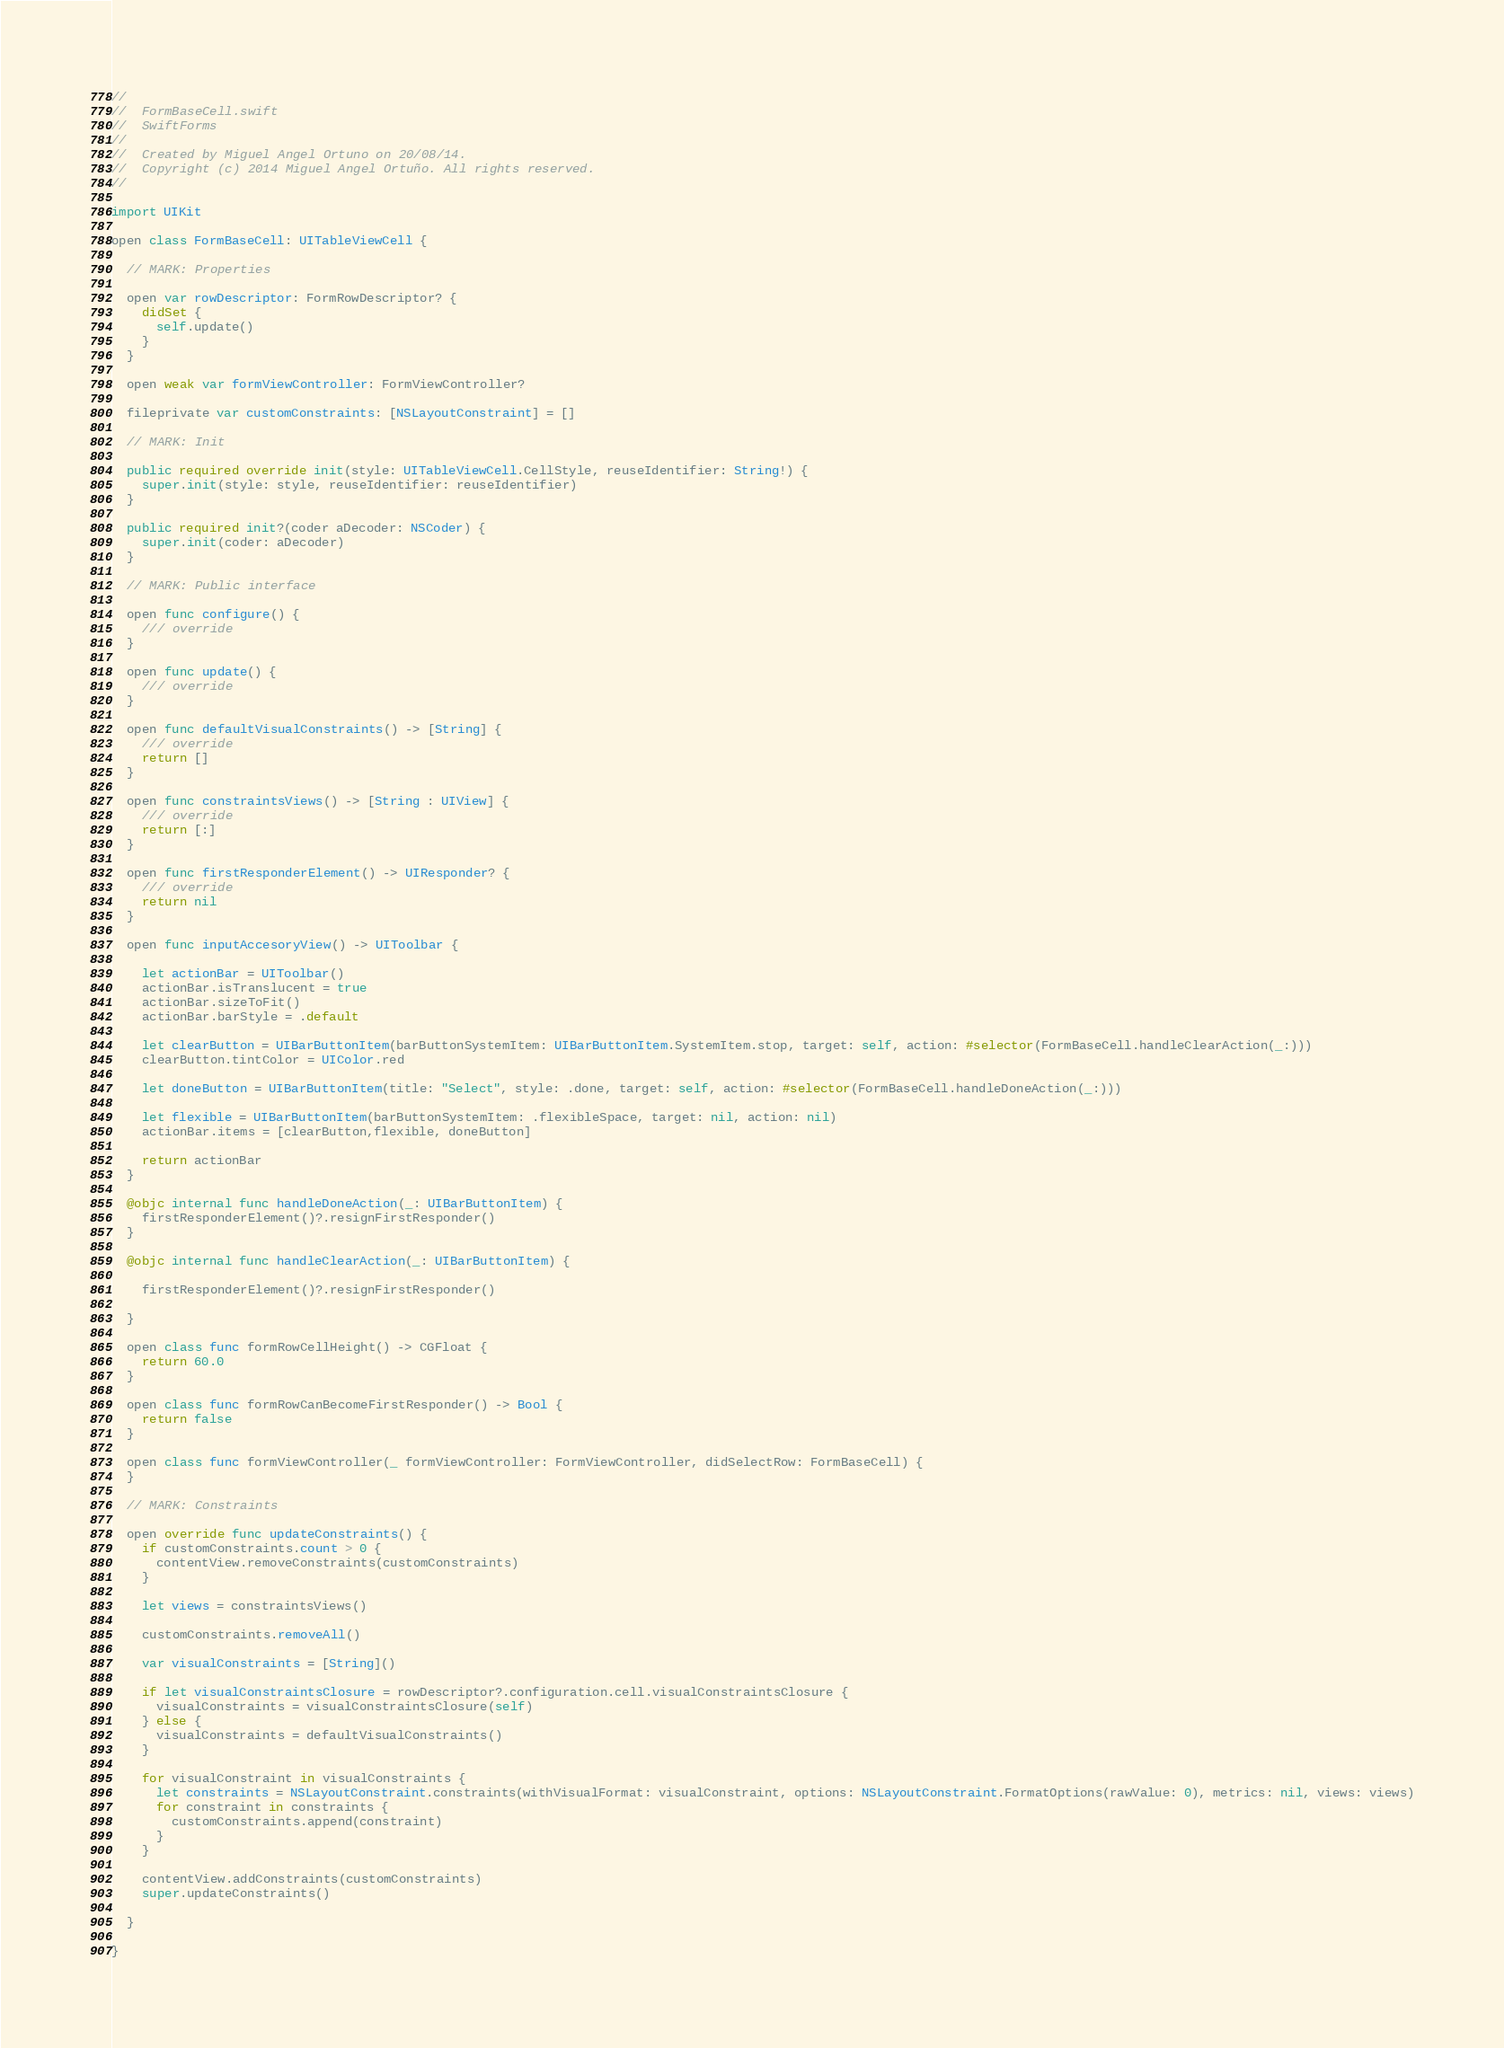Convert code to text. <code><loc_0><loc_0><loc_500><loc_500><_Swift_>//
//  FormBaseCell.swift
//  SwiftForms
//
//  Created by Miguel Angel Ortuno on 20/08/14.
//  Copyright (c) 2014 Miguel Angel Ortuño. All rights reserved.
//

import UIKit

open class FormBaseCell: UITableViewCell {
  
  // MARK: Properties
  
  open var rowDescriptor: FormRowDescriptor? {
    didSet {
      self.update()
    }
  }
  
  open weak var formViewController: FormViewController?
  
  fileprivate var customConstraints: [NSLayoutConstraint] = []
  
  // MARK: Init
  
  public required override init(style: UITableViewCell.CellStyle, reuseIdentifier: String!) {
    super.init(style: style, reuseIdentifier: reuseIdentifier)
  }
  
  public required init?(coder aDecoder: NSCoder) {
    super.init(coder: aDecoder)
  }
  
  // MARK: Public interface
  
  open func configure() {
    /// override
  }
  
  open func update() {
    /// override
  }
  
  open func defaultVisualConstraints() -> [String] {
    /// override
    return []
  }
  
  open func constraintsViews() -> [String : UIView] {
    /// override
    return [:]
  }
  
  open func firstResponderElement() -> UIResponder? {
    /// override
    return nil
  }
  
  open func inputAccesoryView() -> UIToolbar {
    
    let actionBar = UIToolbar()
    actionBar.isTranslucent = true
    actionBar.sizeToFit()
    actionBar.barStyle = .default
    
    let clearButton = UIBarButtonItem(barButtonSystemItem: UIBarButtonItem.SystemItem.stop, target: self, action: #selector(FormBaseCell.handleClearAction(_:)))
    clearButton.tintColor = UIColor.red
    
    let doneButton = UIBarButtonItem(title: "Select", style: .done, target: self, action: #selector(FormBaseCell.handleDoneAction(_:)))
    
    let flexible = UIBarButtonItem(barButtonSystemItem: .flexibleSpace, target: nil, action: nil)
    actionBar.items = [clearButton,flexible, doneButton]
    
    return actionBar
  }
  
  @objc internal func handleDoneAction(_: UIBarButtonItem) {
    firstResponderElement()?.resignFirstResponder()
  }
  
  @objc internal func handleClearAction(_: UIBarButtonItem) {
    
    firstResponderElement()?.resignFirstResponder()
    
  }
  
  open class func formRowCellHeight() -> CGFloat {
    return 60.0
  }
  
  open class func formRowCanBecomeFirstResponder() -> Bool {
    return false
  }
  
  open class func formViewController(_ formViewController: FormViewController, didSelectRow: FormBaseCell) {
  }
  
  // MARK: Constraints
  
  open override func updateConstraints() {
    if customConstraints.count > 0 {
      contentView.removeConstraints(customConstraints)
    }
    
    let views = constraintsViews()
    
    customConstraints.removeAll()
    
    var visualConstraints = [String]()
    
    if let visualConstraintsClosure = rowDescriptor?.configuration.cell.visualConstraintsClosure {
      visualConstraints = visualConstraintsClosure(self)
    } else {
      visualConstraints = defaultVisualConstraints()
    }
    
    for visualConstraint in visualConstraints {
      let constraints = NSLayoutConstraint.constraints(withVisualFormat: visualConstraint, options: NSLayoutConstraint.FormatOptions(rawValue: 0), metrics: nil, views: views)
      for constraint in constraints {
        customConstraints.append(constraint)
      }
    }
    
    contentView.addConstraints(customConstraints)
    super.updateConstraints()
    
  }
  
}
</code> 